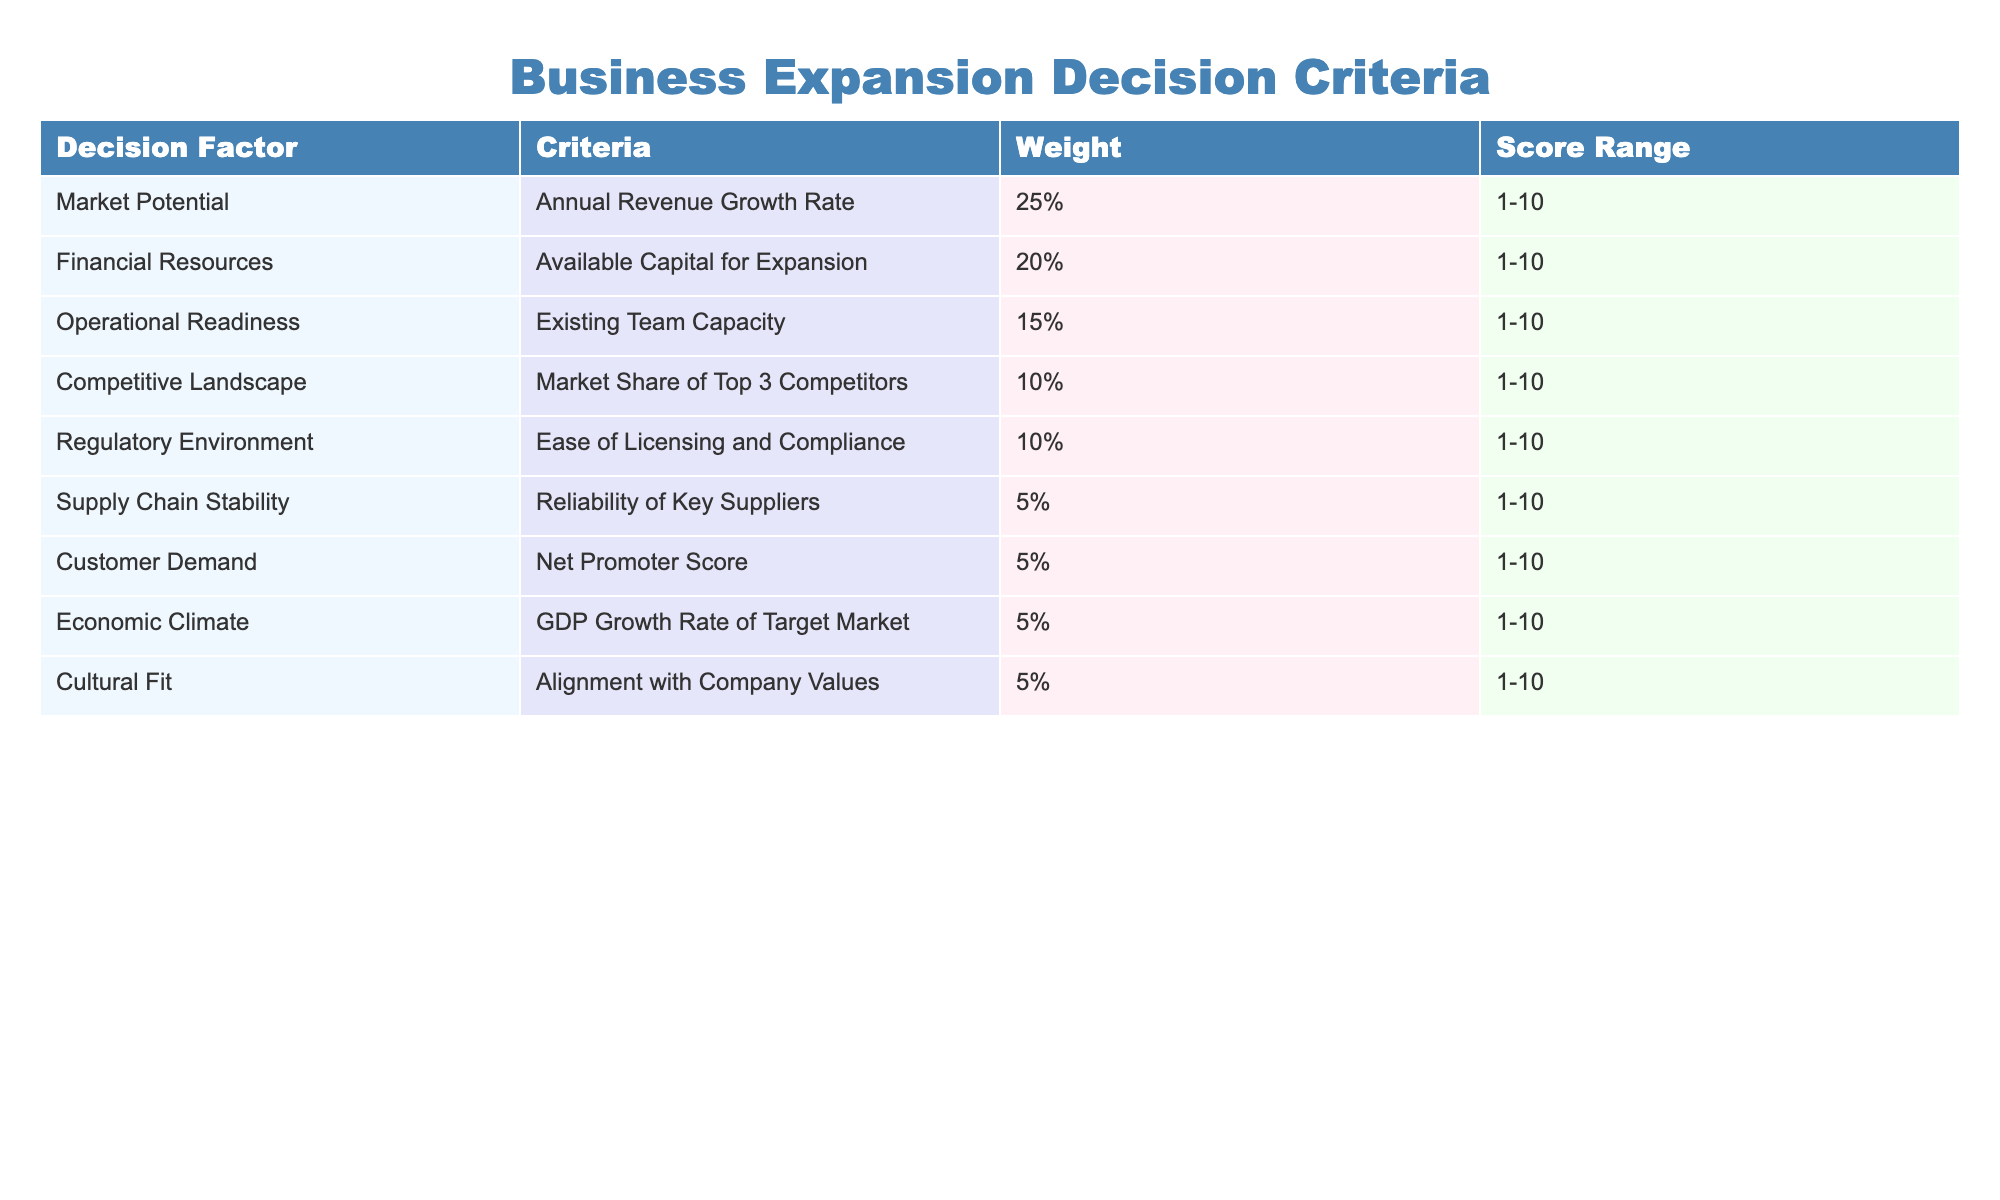What is the weight assigned to Market Potential? The table directly states that the weight assigned to Market Potential is 25%.
Answer: 25% Which decision factor has the lowest weight? By examining the table, Supply Chain Stability has the lowest weight, which is 5%.
Answer: Supply Chain Stability What is the score range for Financial Resources? The table indicates the score range for Financial Resources is 1-10.
Answer: 1-10 What is the combined weight of Competitive Landscape and Regulatory Environment? The weight of Competitive Landscape is 10% and Regulatory Environment is also 10%. Summing these gives 10% + 10% = 20%.
Answer: 20% Is the score range for Customer Demand higher than that for Economic Climate? The score range for both Customer Demand and Economic Climate is 1-10, meaning they are equal. Therefore, the answer is no.
Answer: No What is the average weight for the factors related to growth and demand (Market Potential, Financial Resources, and Customer Demand)? The weights for these factors are 25% (Market Potential), 20% (Financial Resources), and 5% (Customer Demand). The average weight is calculated as (25% + 20% + 5%) / 3 = 50% / 3, which is approximately 16.67%.
Answer: 16.67% Which decision factor has a value for scoring that requires the most steps to evaluate if a business should expand? Assessing the Competitive Landscape would require evaluating the market share of the top 3 competitors, comparing it with one's own share, and analyzing strategic actions to enhance market position, making it complex.
Answer: Competitive Landscape What are the decision factors that have scores based on customer sentiments, and what is their importance score? The decision factors based on customer sentiments are Customer Demand with a weight of 5% and Market Potential with a weight of 25%. Summing them gives an importance score of 30%.
Answer: 30% Is regulatory environment more significant than supply chain stability in terms of weight? The weight for Regulatory Environment is 10%, while for Supply Chain Stability it is 5%. Since 10% is greater than 5%, the answer is yes.
Answer: Yes 